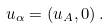<formula> <loc_0><loc_0><loc_500><loc_500>u _ { \alpha } = ( u _ { A } , 0 ) \, .</formula> 